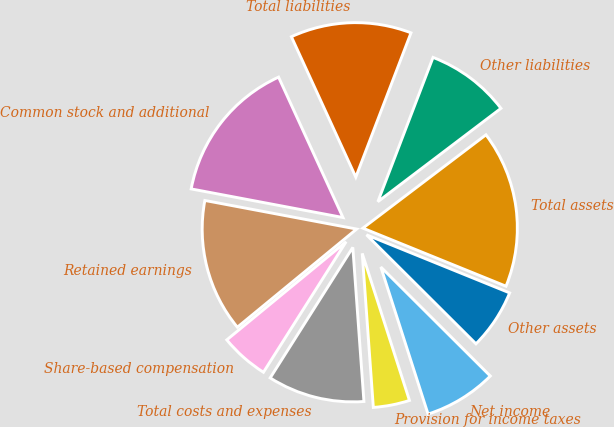Convert chart. <chart><loc_0><loc_0><loc_500><loc_500><pie_chart><fcel>Other assets<fcel>Total assets<fcel>Other liabilities<fcel>Total liabilities<fcel>Common stock and additional<fcel>Retained earnings<fcel>Share-based compensation<fcel>Total costs and expenses<fcel>Provision for income taxes<fcel>Net income<nl><fcel>6.33%<fcel>16.46%<fcel>8.86%<fcel>12.66%<fcel>15.19%<fcel>13.92%<fcel>5.06%<fcel>10.13%<fcel>3.8%<fcel>7.59%<nl></chart> 